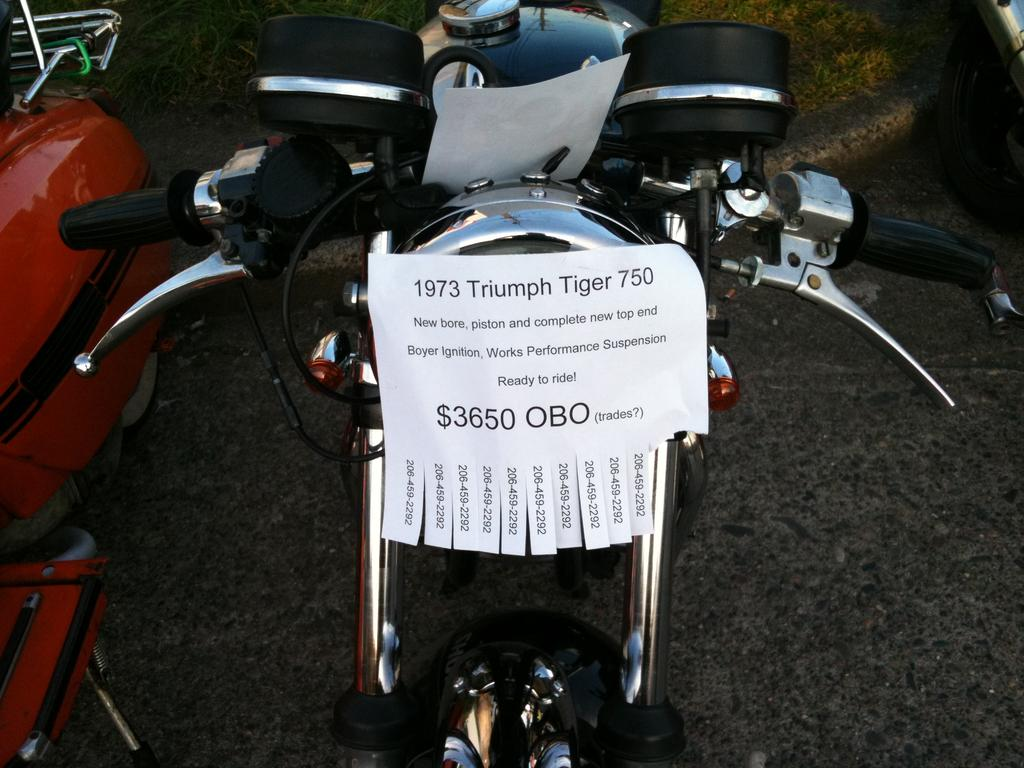What is the main subject in the foreground of the image? There is a vehicle in the foreground of the image. What is on the vehicle? There is paper on the vehicle. What is written on the paper? The paper contains numbers and text. Can you see any fairies flying around the vehicle in the image? There are no fairies present in the image. What type of plant is growing on the vehicle in the image? There is no plant growing on the vehicle in the image. 